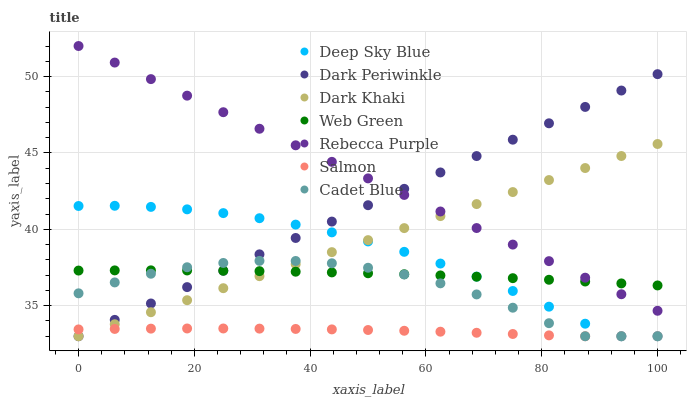Does Salmon have the minimum area under the curve?
Answer yes or no. Yes. Does Rebecca Purple have the maximum area under the curve?
Answer yes or no. Yes. Does Web Green have the minimum area under the curve?
Answer yes or no. No. Does Web Green have the maximum area under the curve?
Answer yes or no. No. Is Rebecca Purple the smoothest?
Answer yes or no. Yes. Is Cadet Blue the roughest?
Answer yes or no. Yes. Is Salmon the smoothest?
Answer yes or no. No. Is Salmon the roughest?
Answer yes or no. No. Does Cadet Blue have the lowest value?
Answer yes or no. Yes. Does Web Green have the lowest value?
Answer yes or no. No. Does Rebecca Purple have the highest value?
Answer yes or no. Yes. Does Web Green have the highest value?
Answer yes or no. No. Is Cadet Blue less than Rebecca Purple?
Answer yes or no. Yes. Is Rebecca Purple greater than Cadet Blue?
Answer yes or no. Yes. Does Web Green intersect Deep Sky Blue?
Answer yes or no. Yes. Is Web Green less than Deep Sky Blue?
Answer yes or no. No. Is Web Green greater than Deep Sky Blue?
Answer yes or no. No. Does Cadet Blue intersect Rebecca Purple?
Answer yes or no. No. 